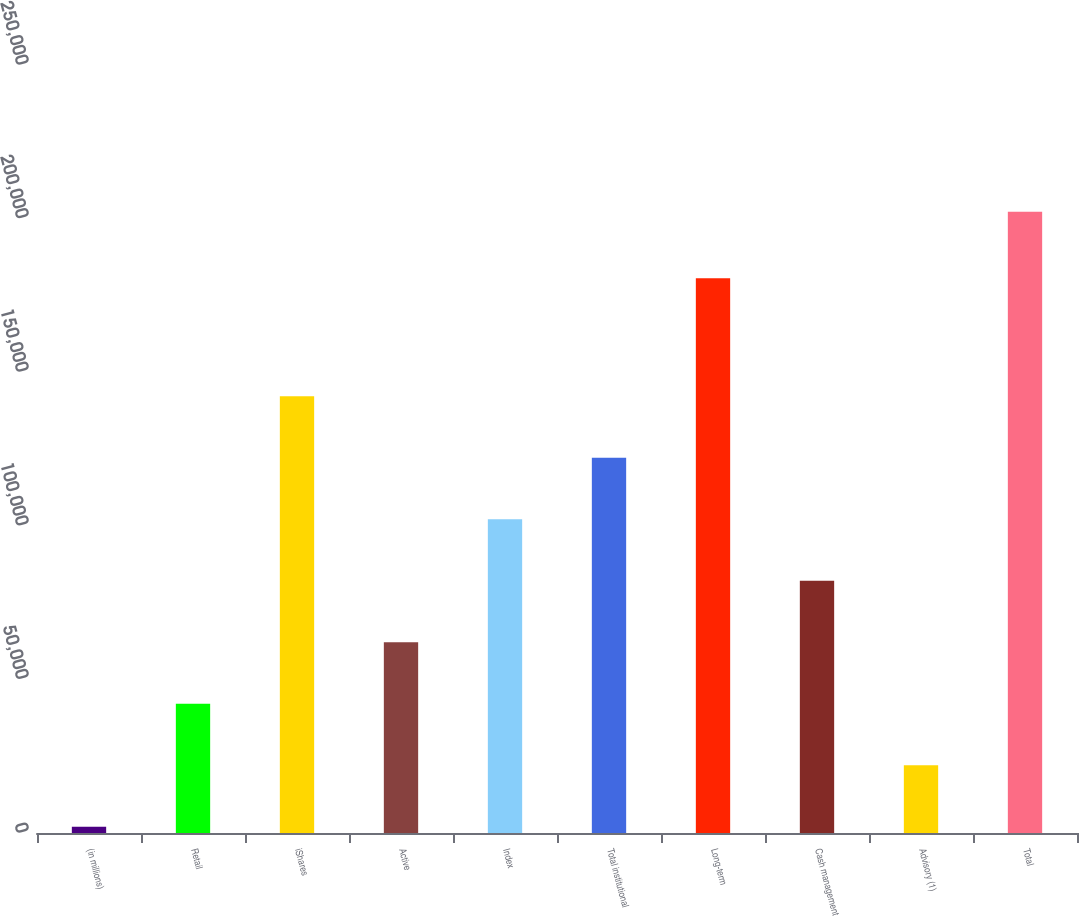Convert chart. <chart><loc_0><loc_0><loc_500><loc_500><bar_chart><fcel>(in millions)<fcel>Retail<fcel>iShares<fcel>Active<fcel>Index<fcel>Total institutional<fcel>Long-term<fcel>Cash management<fcel>Advisory (1)<fcel>Total<nl><fcel>2016<fcel>42051<fcel>142138<fcel>62068.5<fcel>102104<fcel>122121<fcel>180564<fcel>82086<fcel>22033.5<fcel>202191<nl></chart> 